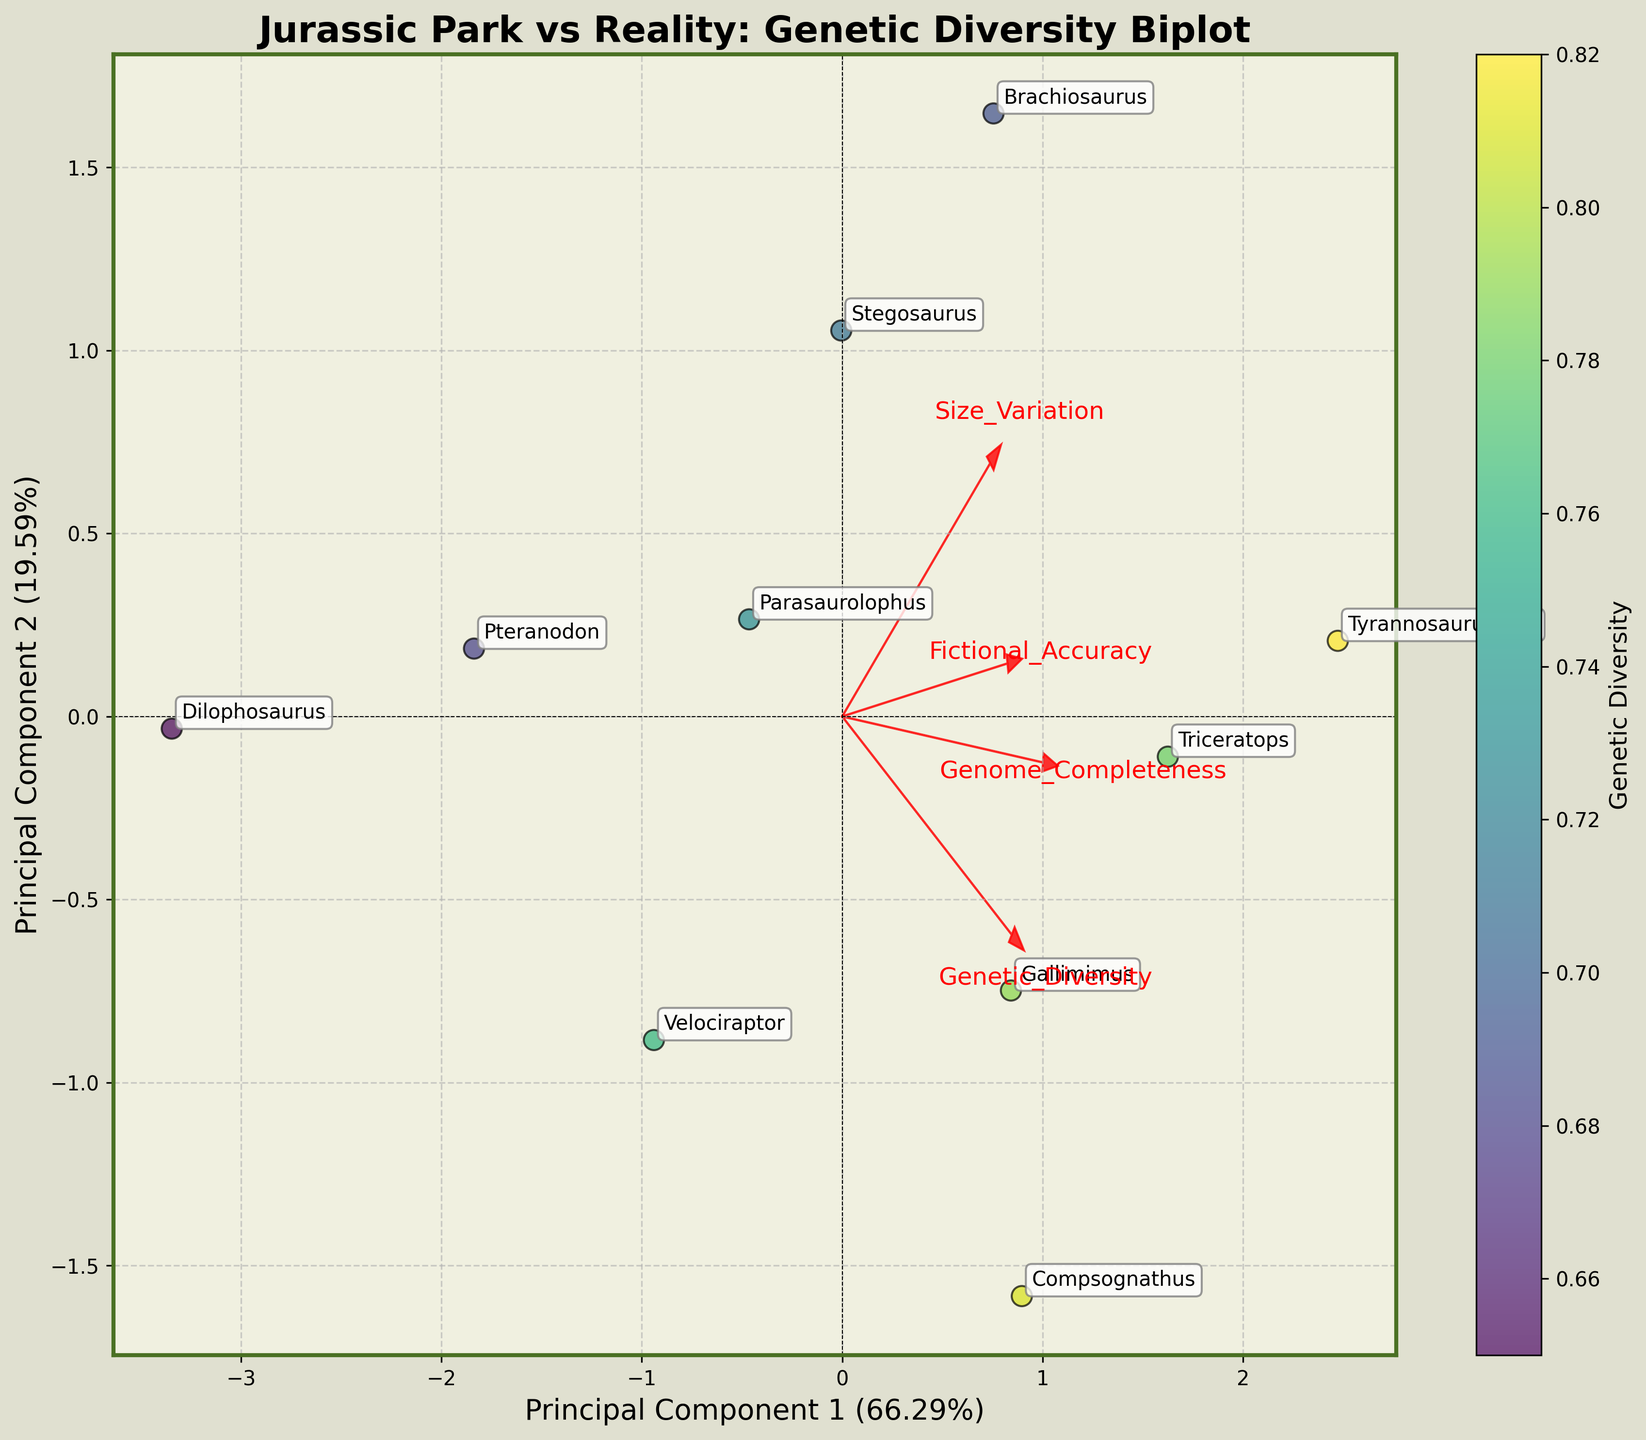How many dinosaur species are plotted on the biplot? The plot includes a data point for each dinosaur species from the dataset. By counting the species labels or scatter plot points, we find there are ten species plotted.
Answer: 10 Which feature has the most influence on Principal Component 1? This can be determined by looking at the length and direction of the feature vectors that align most closely with the x-axis (Principal Component 1). The feature vector that extends farthest along the x-axis suggests the highest influence on PC1.
Answer: Genetic Diversity Is there a significant difference between the Genetic Diversity of Gallimimus and Velociraptor in the plot? Looking at the color shades representing Genetic Diversity, Gallimimus and Velociraptor have different shades of color. Gallimimus is closer to deep yellow (higher Genetic Diversity), whereas Velociraptor is closer to greenish (lower Genetic Diversity).
Answer: Yes Describe the orientation of the Genome Completeness vector in relation to the Principal Component 1 and 2 axes. The vector for Genome Completeness should be observed for its direction and length in the biplot. It points slightly toward the top left quadrant, indicating a positive correlation with PC1 but also some influence on PC2.
Answer: Points towards top left Which species has the highest Fictional Accuracy and where is it located in the biplot? The species with the highest Fictional Accuracy will be closest to the end of the Fictional Accuracy vector. By examining the data points and their proximity to this vector, Gallimimus appears to be closest.
Answer: Gallimimus Compare the relative placement of Triceratops and Dilophosaurus on the biplot. What does it suggest about their genetic features? Triceratops and Dilophosaurus should be located by their PCA scatter points. Triceratops is positioned further right with higher overall values, while Dilophosaurus is lower and to the left, indicating Triceratops generally has higher genetic metrics.
Answer: Triceratops has higher genetic metrics Which two species are positioned closest together, indicating similar genetic profiles in the biplot? By observing the scatter points, the two species that are most closely grouped together suggest they have similar genetic features. Compsognathus and Tyrannosaurus Rex are quite close on the plot.
Answer: Compsognathus and Tyrannosaurus Rex What does the arrow direction of the Size Variation vector tell us about its relationship with the principal components? The direction of the Size Variation vector will highlight its contributions. It points diagonally upwards and right, showing a strong positive correlation with both PC1 and PC2.
Answer: Positive with PC1 and PC2 How does the color gradient vary across Principal Component 1? The color gradient represents Genetic Diversity. Looking across the Principal Component 1 axis, starting from left to right, the colors range from greens to yellows, indicating an increase in Genetic Diversity.
Answer: From green to yellow Which factor shown in the biplot tends to have the least influence on Principal Component 2, and how can you tell? This can be deduced by observing the length and alignment of the factor vectors relative to the y-axis (Principal Component 2). The vector for Fictional Accuracy is shortest in the y direction, suggesting minimal influence on PC2.
Answer: Fictional Accuracy 